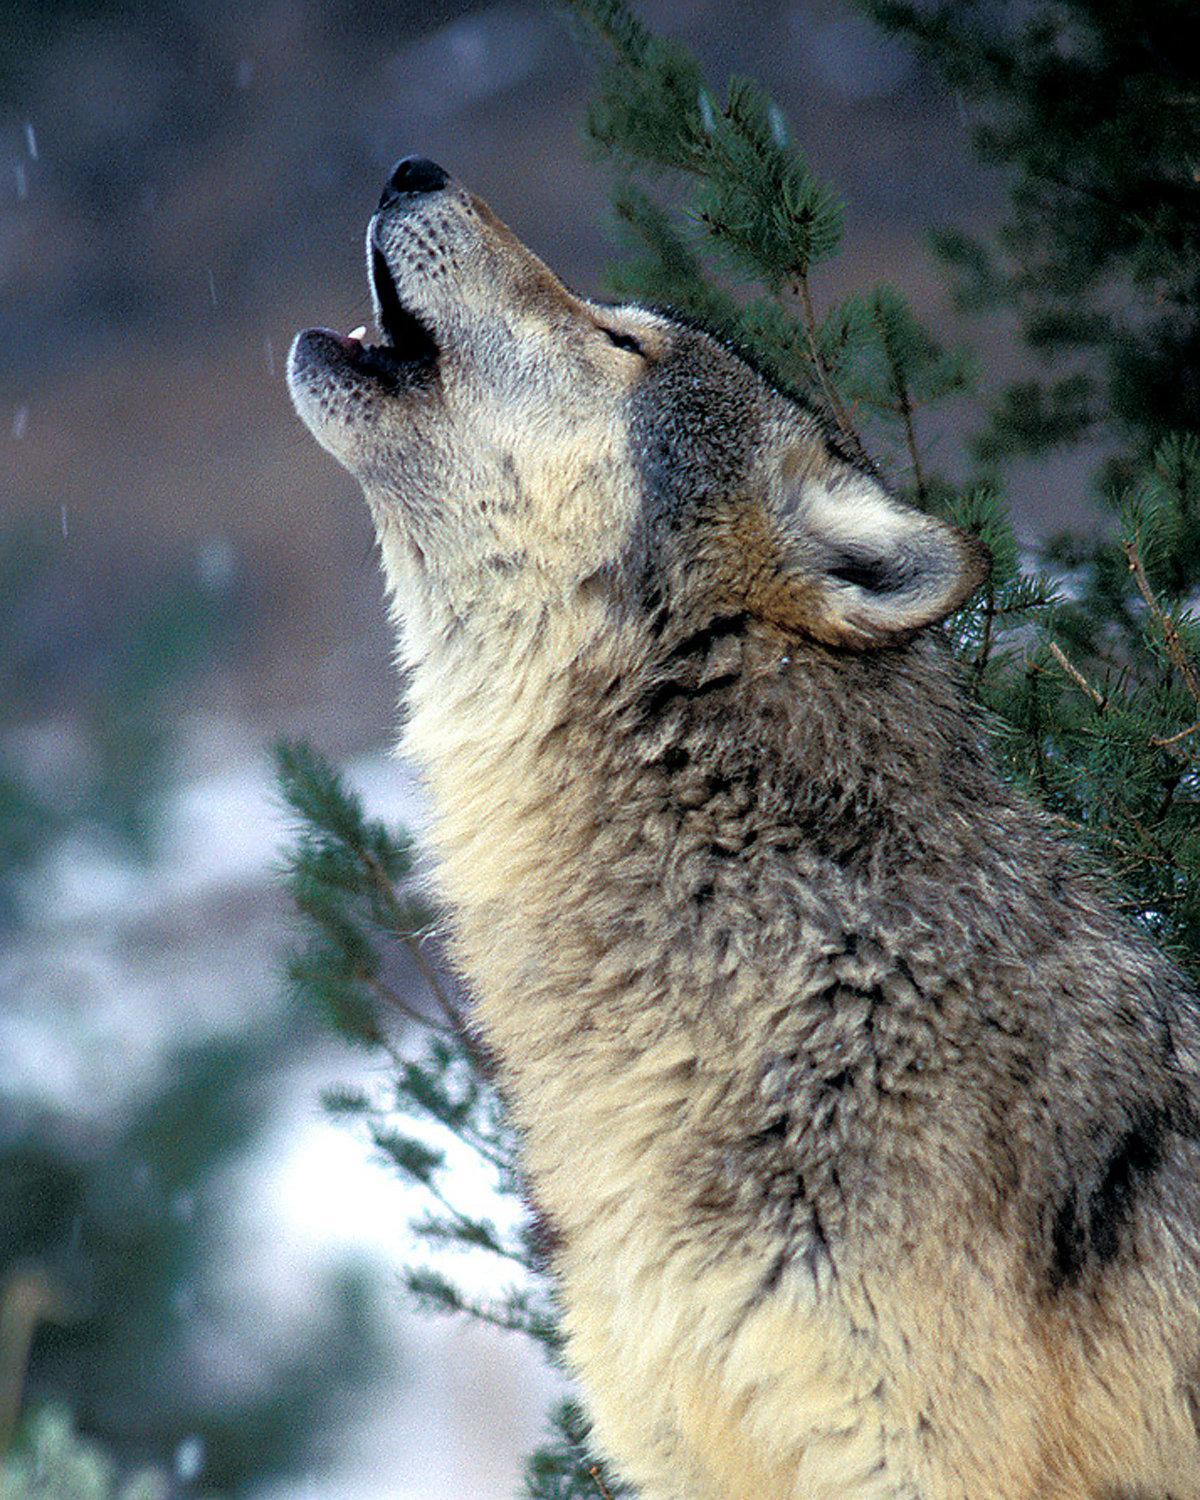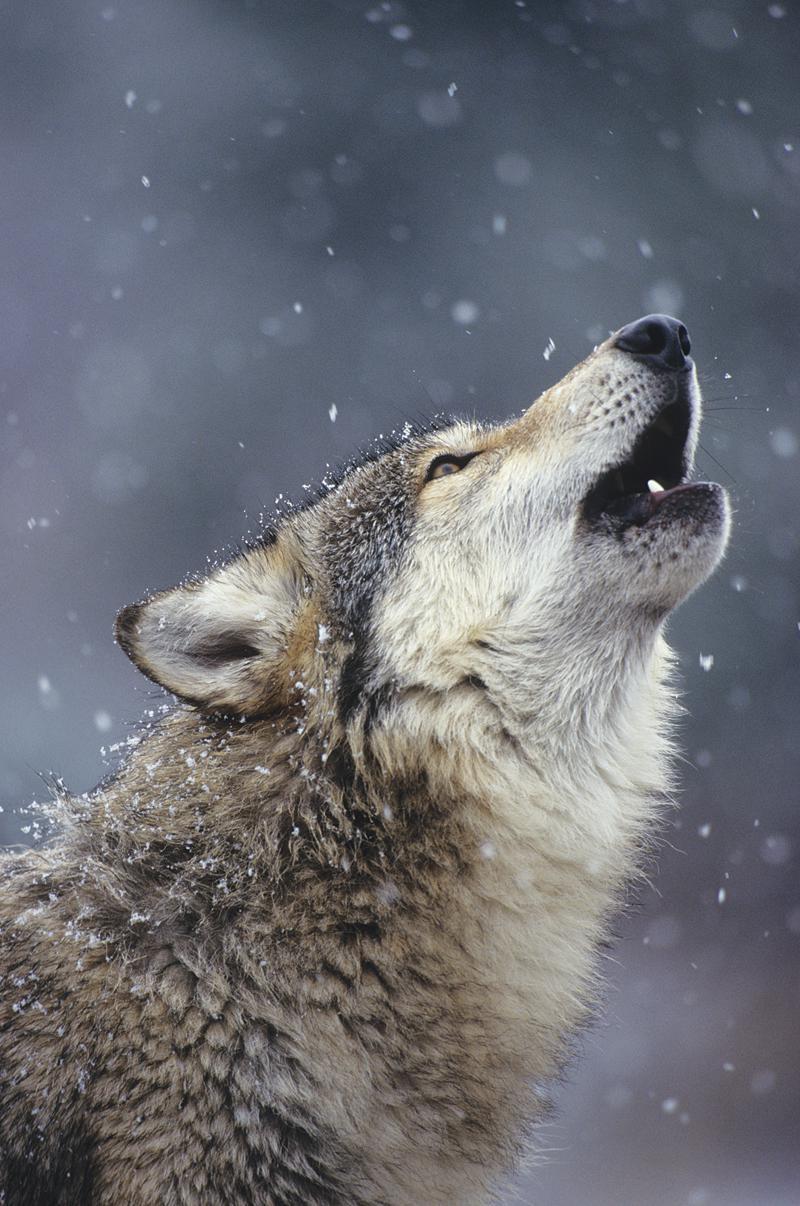The first image is the image on the left, the second image is the image on the right. For the images displayed, is the sentence "Each image shows exactly one howling wolf." factually correct? Answer yes or no. Yes. 